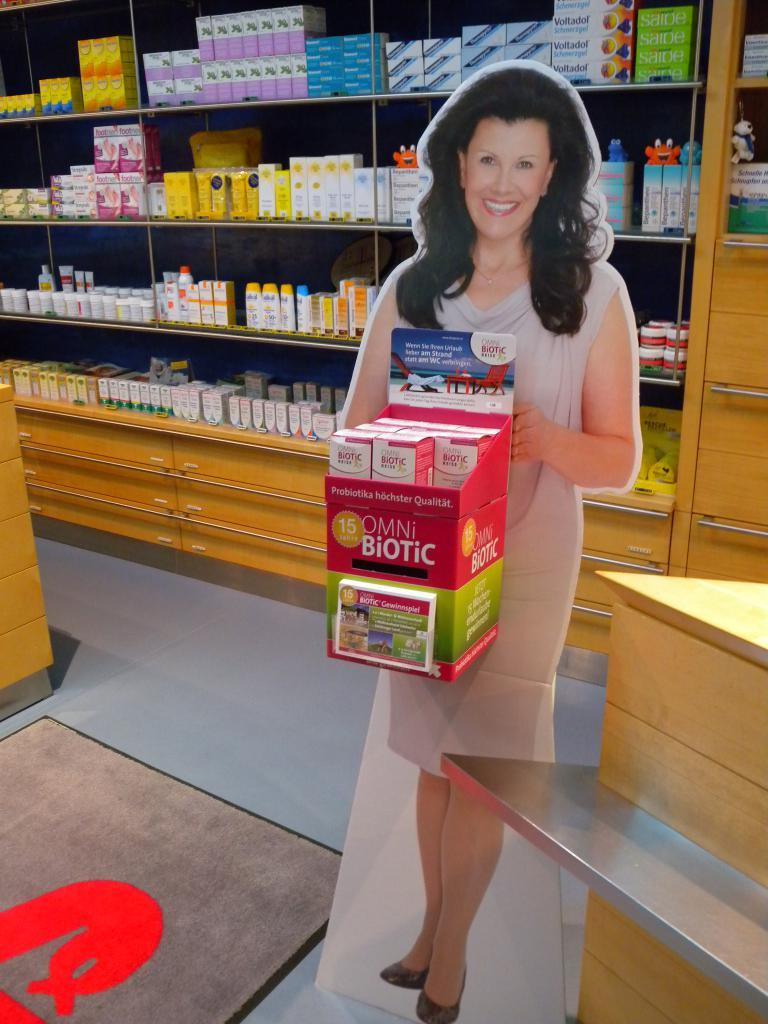Provide a one-sentence caption for the provided image. A cardboard cutout of a lady holding a Biotic box. 